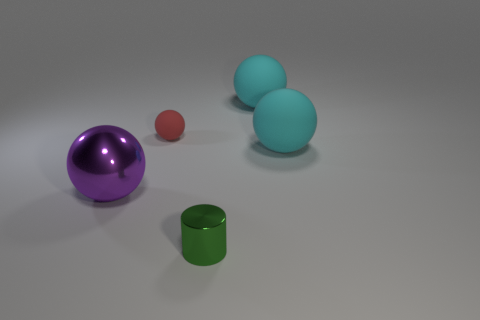Are there any other things of the same color as the small metallic cylinder? Upon examining the image, the small green metallic cylinder is unique in its color when compared to the other objects present. All other items in the image have distinct hues, ensuring the small cylinder's color remains unparalleled within this setting. 